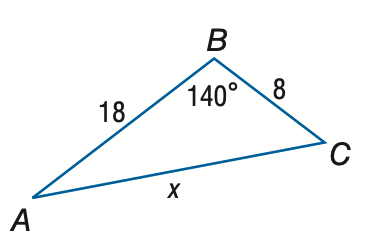Question: Find x. Round to the nearest tenth.
Choices:
A. 12.3
B. 24.7
C. 49.3
D. 74.0
Answer with the letter. Answer: B 